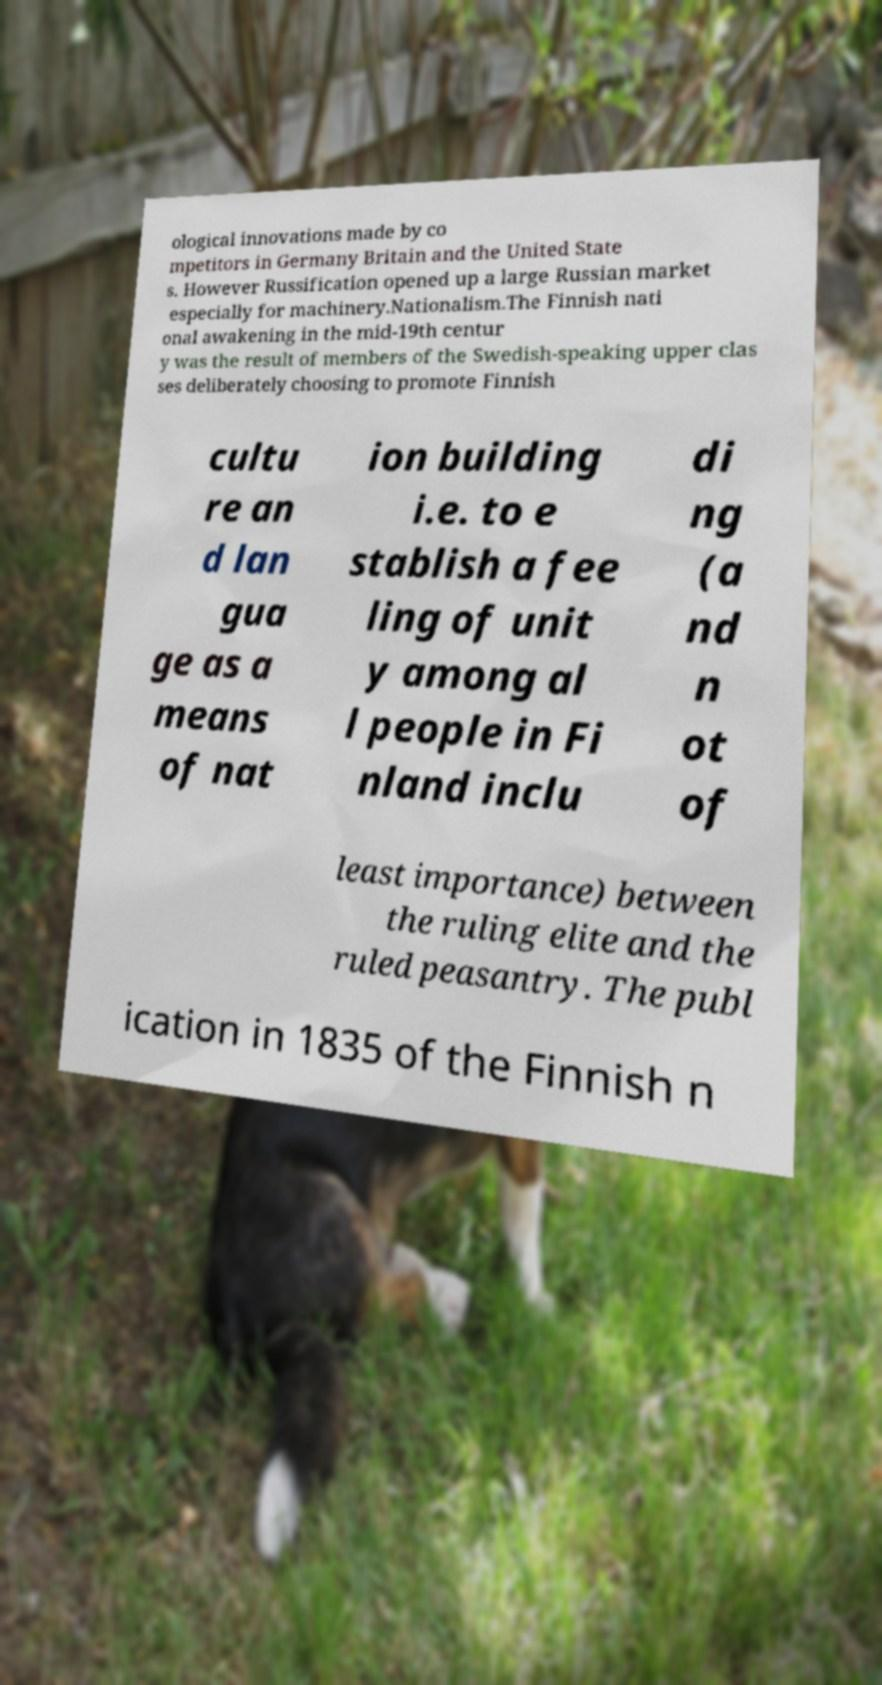There's text embedded in this image that I need extracted. Can you transcribe it verbatim? ological innovations made by co mpetitors in Germany Britain and the United State s. However Russification opened up a large Russian market especially for machinery.Nationalism.The Finnish nati onal awakening in the mid-19th centur y was the result of members of the Swedish-speaking upper clas ses deliberately choosing to promote Finnish cultu re an d lan gua ge as a means of nat ion building i.e. to e stablish a fee ling of unit y among al l people in Fi nland inclu di ng (a nd n ot of least importance) between the ruling elite and the ruled peasantry. The publ ication in 1835 of the Finnish n 